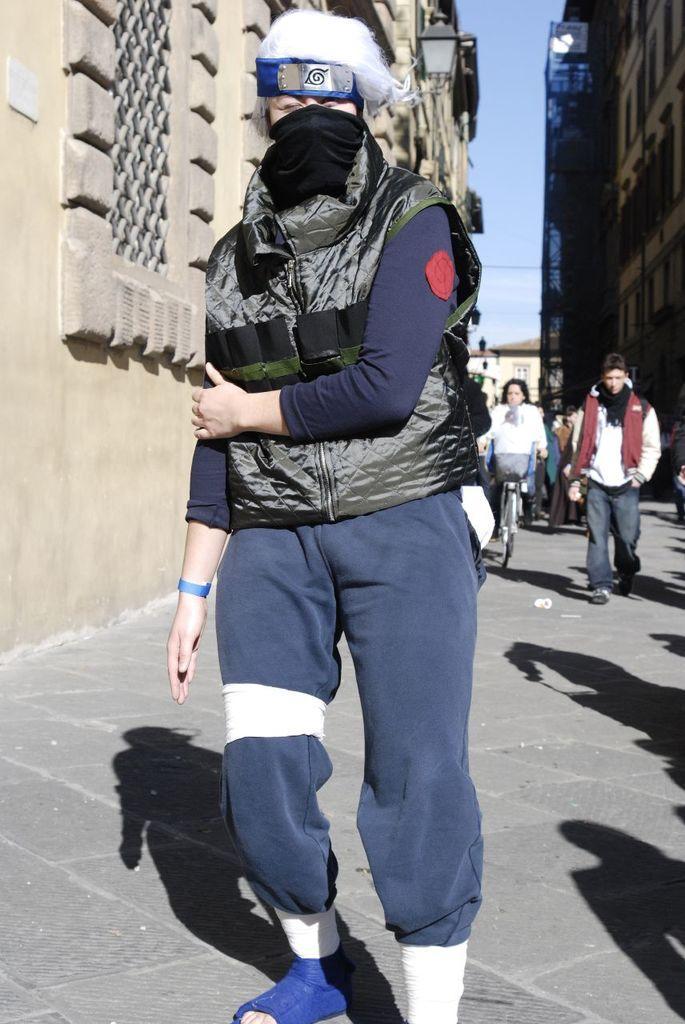Please provide a concise description of this image. Here in this picture, in the front we can see a woman wearing a jacket, carrying a bag and covering her face with a mask and wearing a cap, walking on the ground and behind her also we can see number of people walking and standing on the ground and we can see a woman riding a bicycle and beside them on either side we can see buildings with number of windows present and we can also see lamp posts present and we can see the sky is cloudy. 